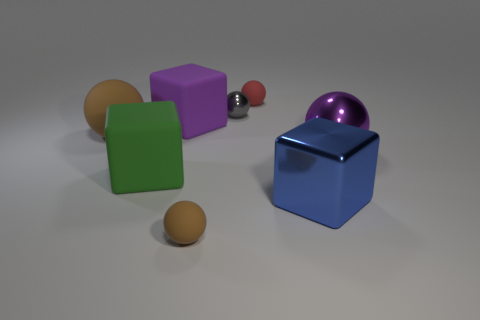What shape is the thing that is the same color as the big metal sphere?
Your answer should be compact. Cube. How many other things are there of the same size as the red thing?
Provide a short and direct response. 2. There is a brown rubber thing that is on the right side of the big brown rubber object; is its size the same as the shiny ball that is in front of the big brown rubber object?
Give a very brief answer. No. What number of things are big brown spheres or brown matte spheres in front of the big green matte block?
Provide a succinct answer. 2. How big is the shiny ball in front of the small gray sphere?
Keep it short and to the point. Large. Is the number of large purple shiny balls that are on the left side of the tiny gray ball less than the number of brown matte balls on the left side of the purple matte cube?
Offer a terse response. Yes. What material is the object that is behind the large brown matte sphere and in front of the gray ball?
Offer a terse response. Rubber. There is a purple thing on the right side of the tiny rubber object behind the big purple shiny thing; what shape is it?
Offer a very short reply. Sphere. How many gray objects are either tiny spheres or big matte blocks?
Your answer should be compact. 1. There is a large brown matte sphere; are there any purple cubes behind it?
Your answer should be very brief. Yes. 